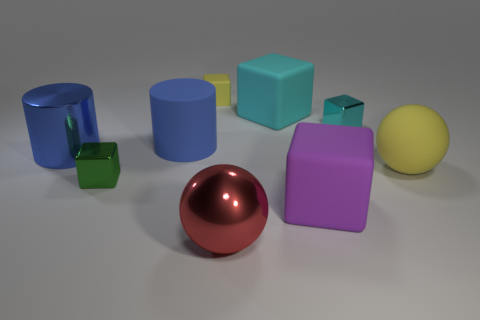What shape is the yellow object in front of the blue rubber cylinder?
Make the answer very short. Sphere. What is the shape of the yellow thing that is the same size as the red metal object?
Ensure brevity in your answer.  Sphere. Is there a purple matte object that has the same shape as the tiny cyan metal object?
Make the answer very short. Yes. There is a tiny shiny thing on the right side of the green shiny cube; is it the same shape as the large metallic thing that is on the right side of the blue shiny cylinder?
Keep it short and to the point. No. There is a blue cylinder that is the same size as the blue matte object; what is its material?
Offer a terse response. Metal. How many other things are there of the same material as the small yellow block?
Your answer should be compact. 4. There is a yellow thing that is to the left of the shiny block that is behind the large metal cylinder; what shape is it?
Keep it short and to the point. Cube. What number of things are tiny shiny cubes or big metal objects that are behind the big red metallic object?
Your response must be concise. 3. What number of other things are there of the same color as the metal sphere?
Your answer should be compact. 0. What number of brown things are either shiny cylinders or rubber spheres?
Your response must be concise. 0. 